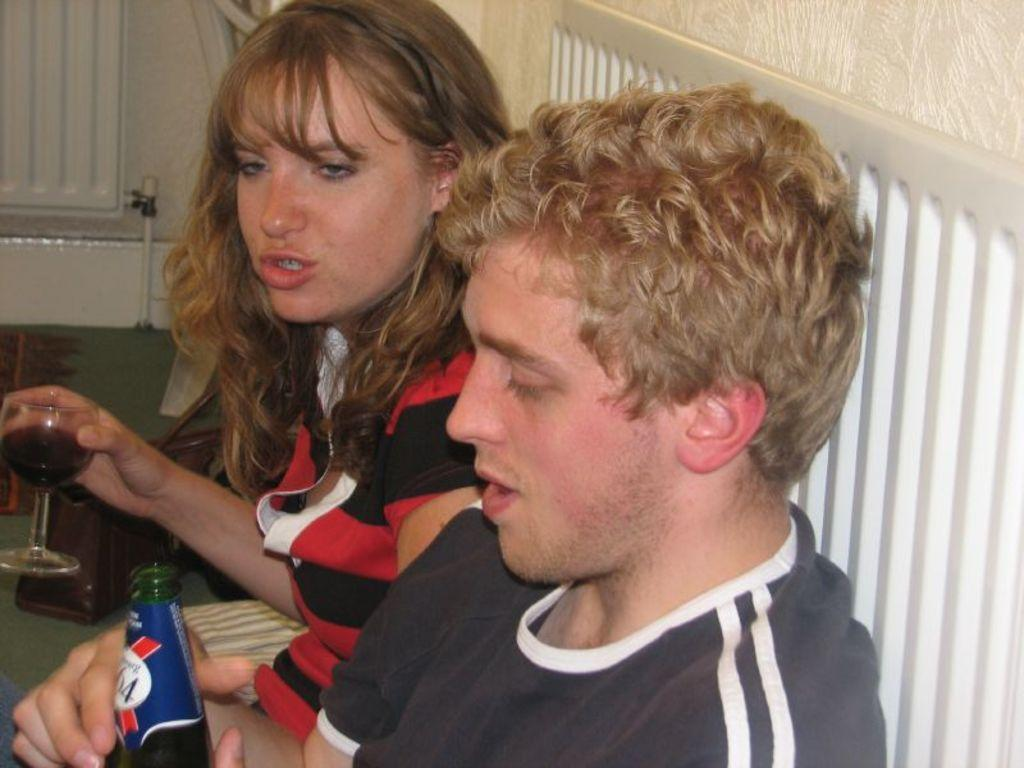What is the man in the image holding? The man is holding a bottle. What is the woman in the image holding? The woman is holding a glass. What can be seen in the background of the image? There is a wall in the background of the image. How many boats are visible in the image? There are no boats present in the image. What type of dog can be seen interacting with the man in the image? There is no dog present in the image; the man is holding a bottle. 